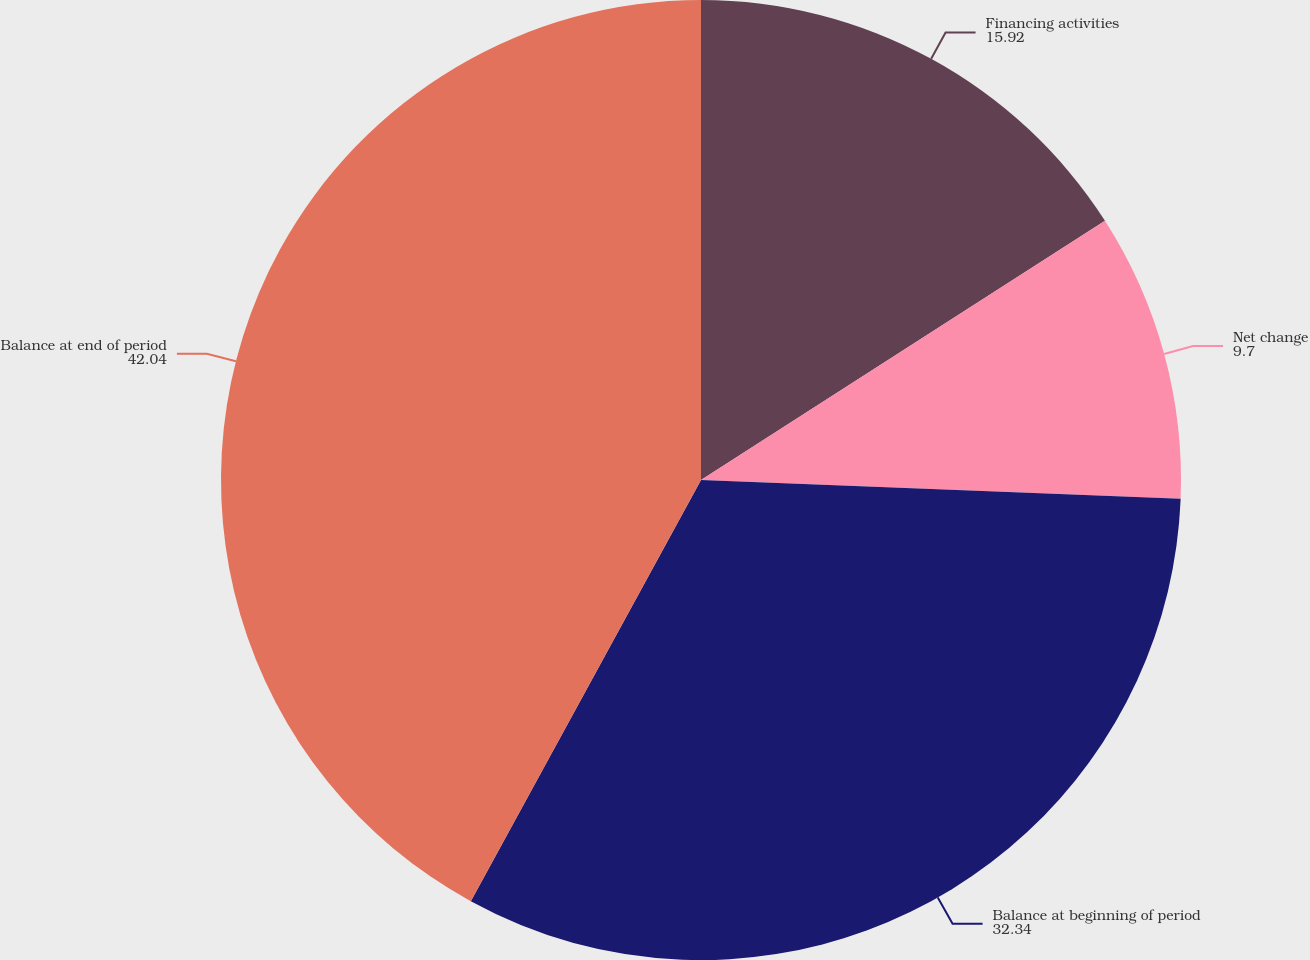Convert chart to OTSL. <chart><loc_0><loc_0><loc_500><loc_500><pie_chart><fcel>Financing activities<fcel>Net change<fcel>Balance at beginning of period<fcel>Balance at end of period<nl><fcel>15.92%<fcel>9.7%<fcel>32.34%<fcel>42.04%<nl></chart> 